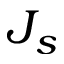Convert formula to latex. <formula><loc_0><loc_0><loc_500><loc_500>J _ { s }</formula> 